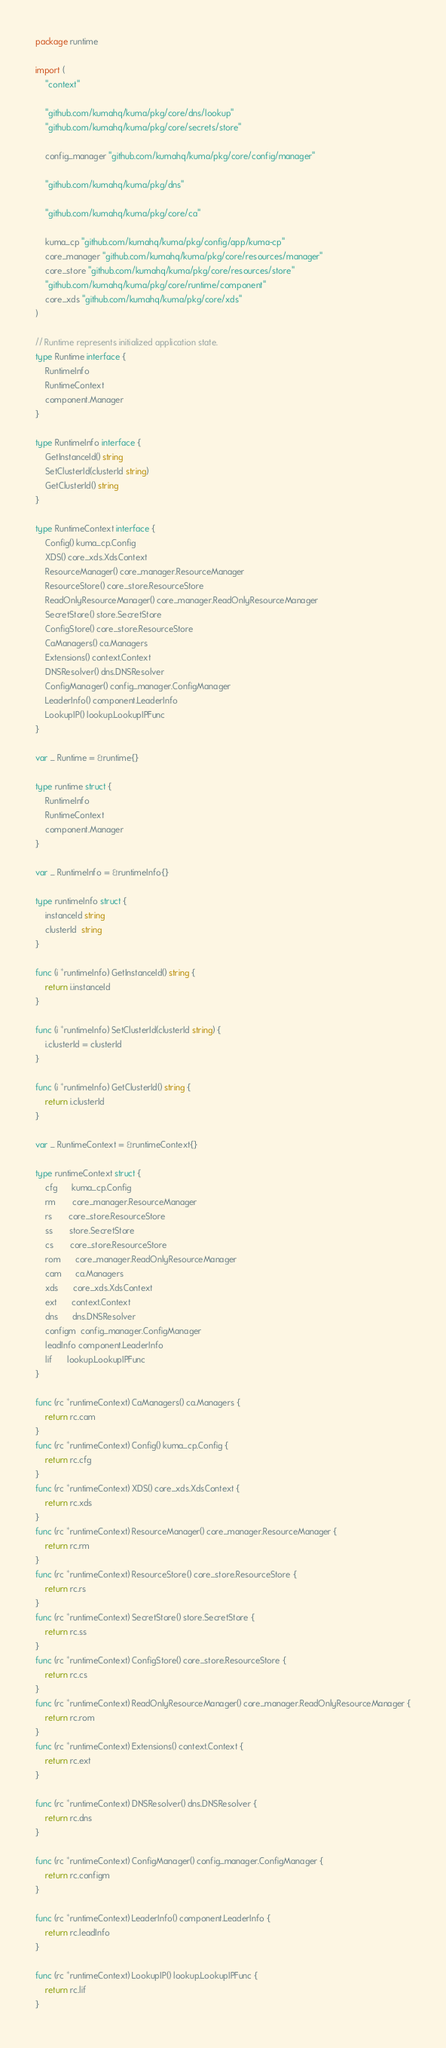<code> <loc_0><loc_0><loc_500><loc_500><_Go_>package runtime

import (
	"context"

	"github.com/kumahq/kuma/pkg/core/dns/lookup"
	"github.com/kumahq/kuma/pkg/core/secrets/store"

	config_manager "github.com/kumahq/kuma/pkg/core/config/manager"

	"github.com/kumahq/kuma/pkg/dns"

	"github.com/kumahq/kuma/pkg/core/ca"

	kuma_cp "github.com/kumahq/kuma/pkg/config/app/kuma-cp"
	core_manager "github.com/kumahq/kuma/pkg/core/resources/manager"
	core_store "github.com/kumahq/kuma/pkg/core/resources/store"
	"github.com/kumahq/kuma/pkg/core/runtime/component"
	core_xds "github.com/kumahq/kuma/pkg/core/xds"
)

// Runtime represents initialized application state.
type Runtime interface {
	RuntimeInfo
	RuntimeContext
	component.Manager
}

type RuntimeInfo interface {
	GetInstanceId() string
	SetClusterId(clusterId string)
	GetClusterId() string
}

type RuntimeContext interface {
	Config() kuma_cp.Config
	XDS() core_xds.XdsContext
	ResourceManager() core_manager.ResourceManager
	ResourceStore() core_store.ResourceStore
	ReadOnlyResourceManager() core_manager.ReadOnlyResourceManager
	SecretStore() store.SecretStore
	ConfigStore() core_store.ResourceStore
	CaManagers() ca.Managers
	Extensions() context.Context
	DNSResolver() dns.DNSResolver
	ConfigManager() config_manager.ConfigManager
	LeaderInfo() component.LeaderInfo
	LookupIP() lookup.LookupIPFunc
}

var _ Runtime = &runtime{}

type runtime struct {
	RuntimeInfo
	RuntimeContext
	component.Manager
}

var _ RuntimeInfo = &runtimeInfo{}

type runtimeInfo struct {
	instanceId string
	clusterId  string
}

func (i *runtimeInfo) GetInstanceId() string {
	return i.instanceId
}

func (i *runtimeInfo) SetClusterId(clusterId string) {
	i.clusterId = clusterId
}

func (i *runtimeInfo) GetClusterId() string {
	return i.clusterId
}

var _ RuntimeContext = &runtimeContext{}

type runtimeContext struct {
	cfg      kuma_cp.Config
	rm       core_manager.ResourceManager
	rs       core_store.ResourceStore
	ss       store.SecretStore
	cs       core_store.ResourceStore
	rom      core_manager.ReadOnlyResourceManager
	cam      ca.Managers
	xds      core_xds.XdsContext
	ext      context.Context
	dns      dns.DNSResolver
	configm  config_manager.ConfigManager
	leadInfo component.LeaderInfo
	lif      lookup.LookupIPFunc
}

func (rc *runtimeContext) CaManagers() ca.Managers {
	return rc.cam
}
func (rc *runtimeContext) Config() kuma_cp.Config {
	return rc.cfg
}
func (rc *runtimeContext) XDS() core_xds.XdsContext {
	return rc.xds
}
func (rc *runtimeContext) ResourceManager() core_manager.ResourceManager {
	return rc.rm
}
func (rc *runtimeContext) ResourceStore() core_store.ResourceStore {
	return rc.rs
}
func (rc *runtimeContext) SecretStore() store.SecretStore {
	return rc.ss
}
func (rc *runtimeContext) ConfigStore() core_store.ResourceStore {
	return rc.cs
}
func (rc *runtimeContext) ReadOnlyResourceManager() core_manager.ReadOnlyResourceManager {
	return rc.rom
}
func (rc *runtimeContext) Extensions() context.Context {
	return rc.ext
}

func (rc *runtimeContext) DNSResolver() dns.DNSResolver {
	return rc.dns
}

func (rc *runtimeContext) ConfigManager() config_manager.ConfigManager {
	return rc.configm
}

func (rc *runtimeContext) LeaderInfo() component.LeaderInfo {
	return rc.leadInfo
}

func (rc *runtimeContext) LookupIP() lookup.LookupIPFunc {
	return rc.lif
}
</code> 